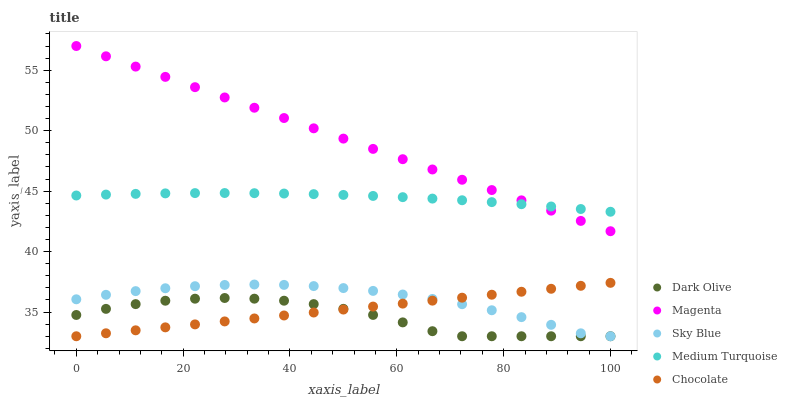Does Dark Olive have the minimum area under the curve?
Answer yes or no. Yes. Does Magenta have the maximum area under the curve?
Answer yes or no. Yes. Does Magenta have the minimum area under the curve?
Answer yes or no. No. Does Dark Olive have the maximum area under the curve?
Answer yes or no. No. Is Chocolate the smoothest?
Answer yes or no. Yes. Is Dark Olive the roughest?
Answer yes or no. Yes. Is Magenta the smoothest?
Answer yes or no. No. Is Magenta the roughest?
Answer yes or no. No. Does Sky Blue have the lowest value?
Answer yes or no. Yes. Does Magenta have the lowest value?
Answer yes or no. No. Does Magenta have the highest value?
Answer yes or no. Yes. Does Dark Olive have the highest value?
Answer yes or no. No. Is Dark Olive less than Magenta?
Answer yes or no. Yes. Is Magenta greater than Sky Blue?
Answer yes or no. Yes. Does Dark Olive intersect Chocolate?
Answer yes or no. Yes. Is Dark Olive less than Chocolate?
Answer yes or no. No. Is Dark Olive greater than Chocolate?
Answer yes or no. No. Does Dark Olive intersect Magenta?
Answer yes or no. No. 